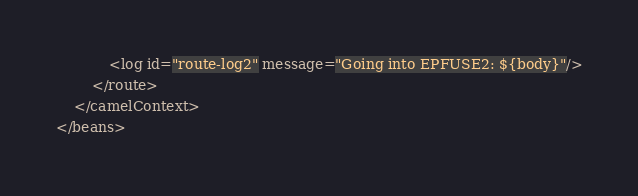<code> <loc_0><loc_0><loc_500><loc_500><_XML_>            <log id="route-log2" message="Going into EPFUSE2: ${body}"/>
        </route>
    </camelContext>
</beans>
</code> 